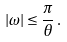<formula> <loc_0><loc_0><loc_500><loc_500>| \omega | \leq \frac { \pi } { \theta } \, .</formula> 